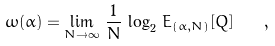Convert formula to latex. <formula><loc_0><loc_0><loc_500><loc_500>\omega ( \alpha ) = \lim _ { N \to \infty } \, \frac { 1 } { N } \, \log _ { 2 } \, E _ { ( \alpha , N ) } [ Q ] \quad ,</formula> 